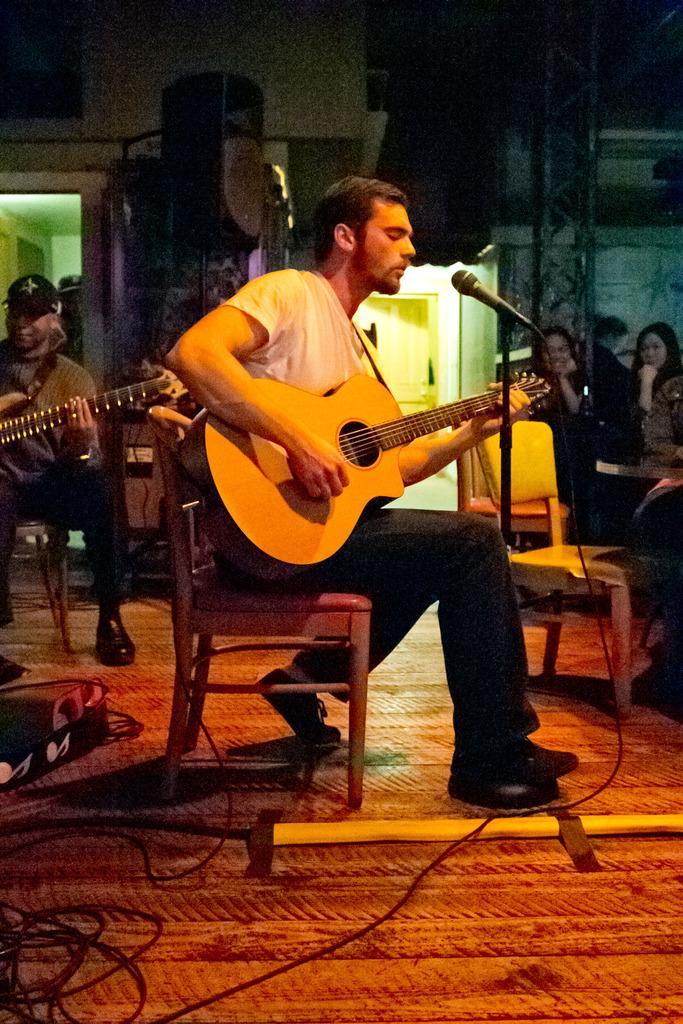How would you summarize this image in a sentence or two? In this picture there is a man who is playing a guitar. There are two women sitting on the chair. There is also another man sitting and playing guitar. 